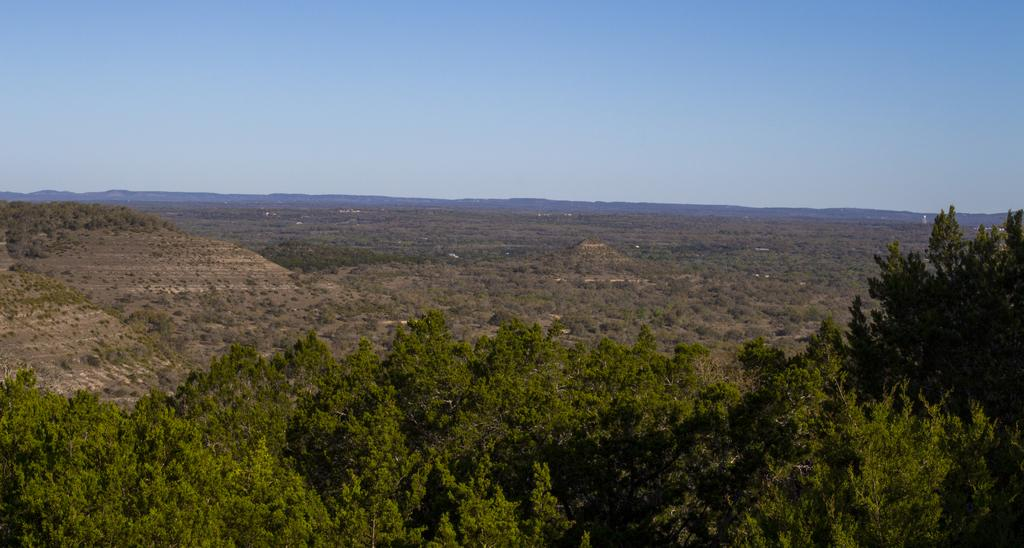What can be seen in the background of the image? There is a sky visible in the background of the image, along with hills. What type of vegetation is present in the image? There is a thicket in the image, and trees are present at the bottom portion of the image. What type of hat is the organization wearing in the image? There is no organization or hat present in the image. What type of building can be seen in the image? There is no building present in the image; it features a sky, hills, a thicket, and trees. 